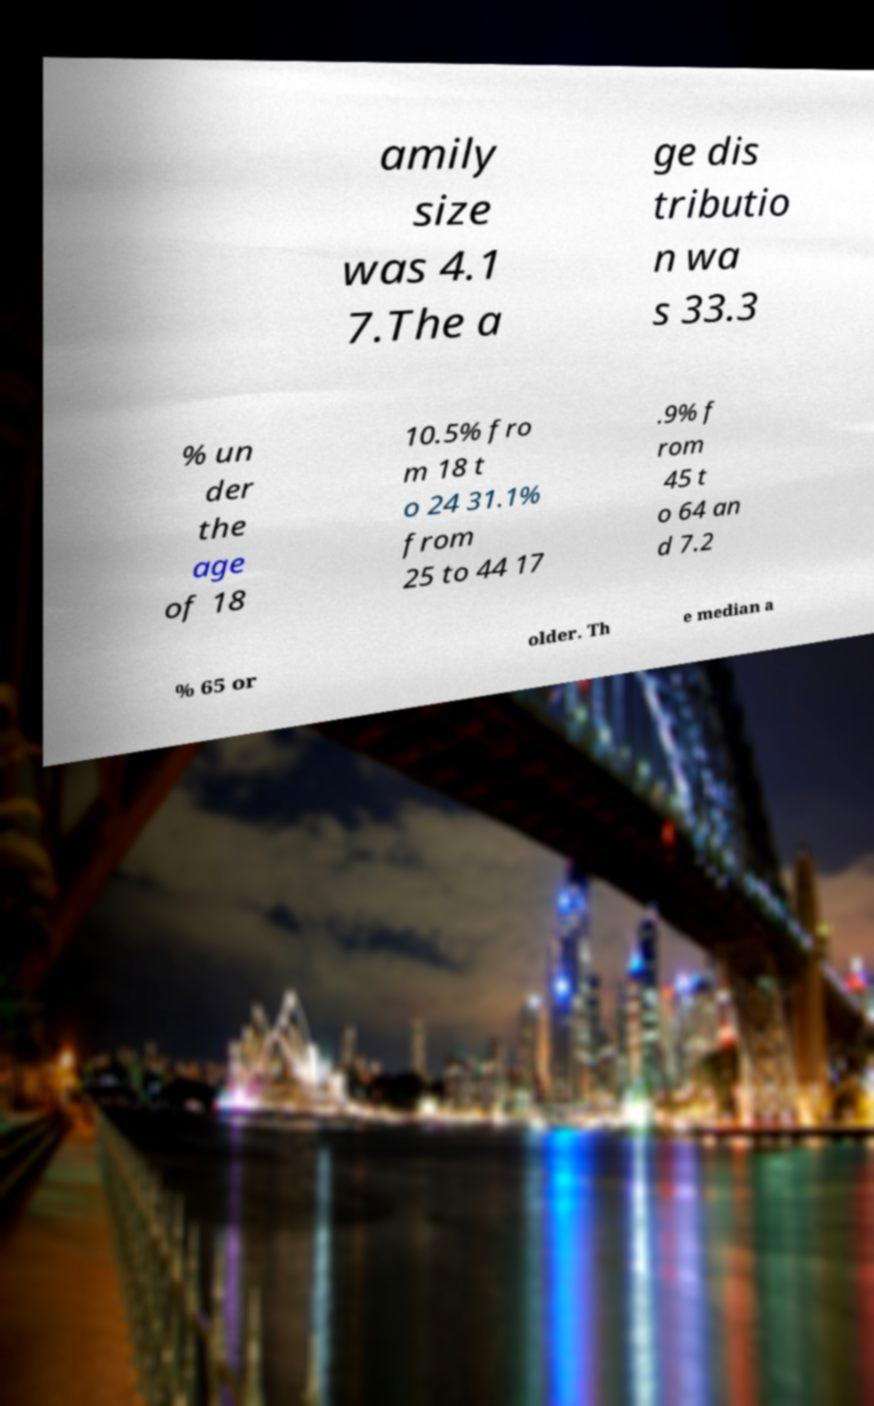What messages or text are displayed in this image? I need them in a readable, typed format. amily size was 4.1 7.The a ge dis tributio n wa s 33.3 % un der the age of 18 10.5% fro m 18 t o 24 31.1% from 25 to 44 17 .9% f rom 45 t o 64 an d 7.2 % 65 or older. Th e median a 